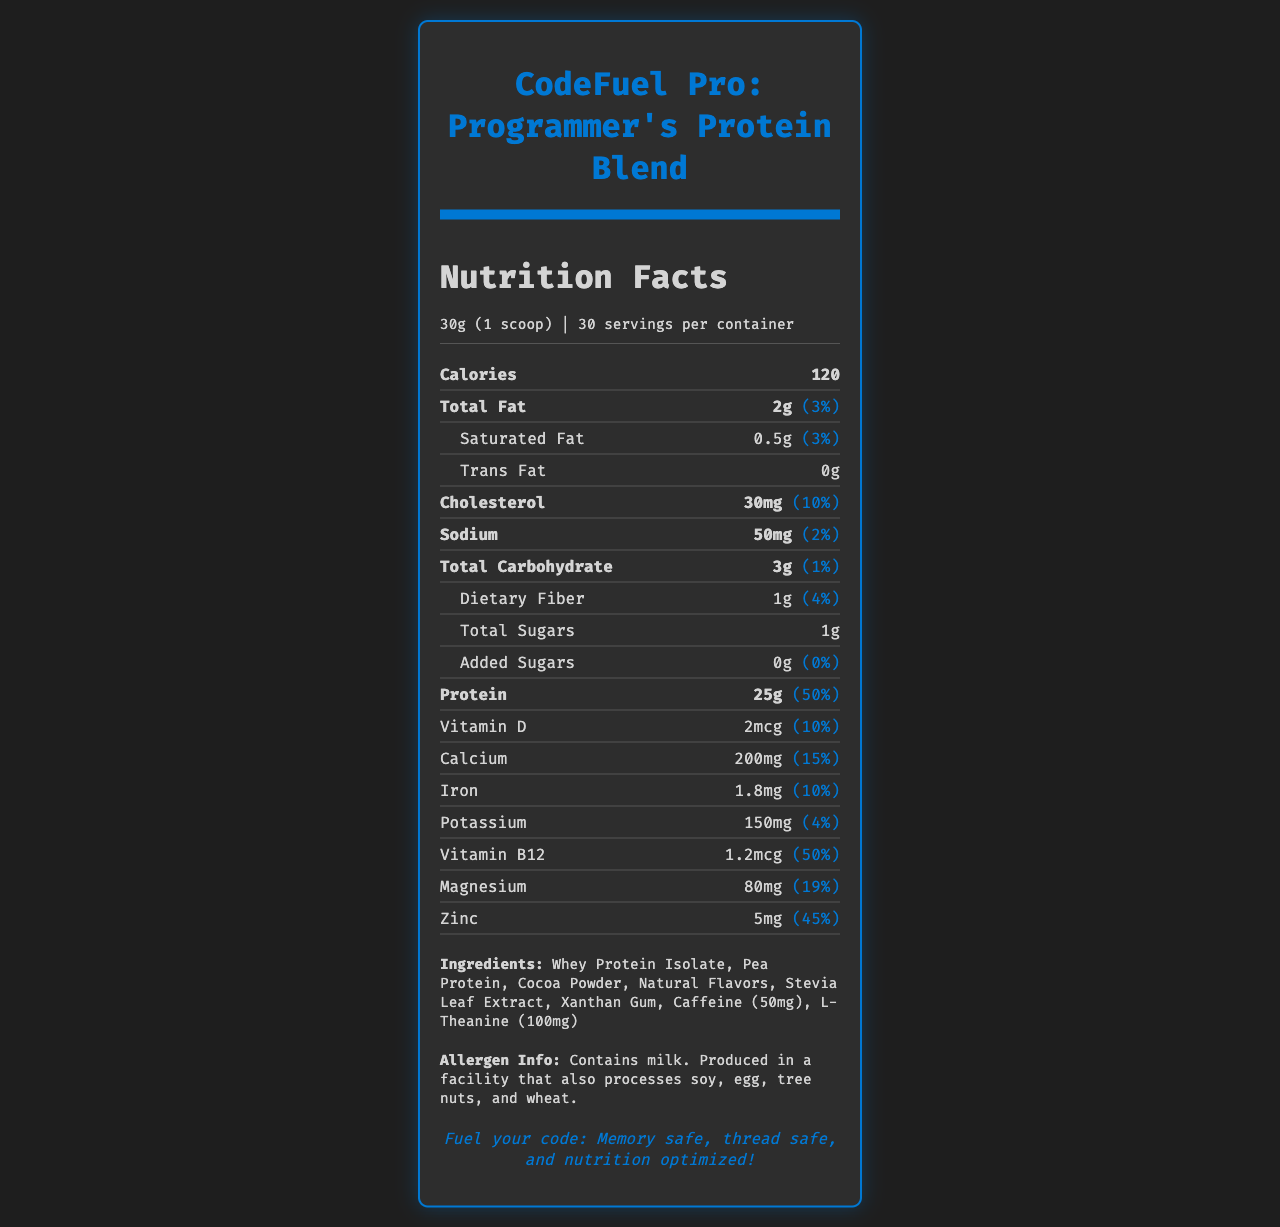What is the serving size of CodeFuel Pro? The serving size is clearly listed under the product name and nutrition facts.
Answer: 30g (1 scoop) How many calories are in one serving? The number of calories per serving is listed under the nutrition section.
Answer: 120 How much protein does one serving provide? The amount of protein per serving is listed in the nutrition facts.
Answer: 25g What is the daily value percentage for protein in one serving? The daily value percentage for protein is shown next to the protein amount in the nutrition facts.
Answer: 50% How much caffeine does one serving contain? Caffeine is listed as one of the ingredients with its specific amount.
Answer: 50mg How many servings are there in one container? The number of servings per container is stated in the serving information section.
Answer: 30 What is the amount of dietary fiber in one serving? The amount of dietary fiber is listed under the carbohydrates section of the nutrition facts.
Answer: 1g What is the storage recommendation for this product? The storage instructions are provided at the end of the document.
Answer: Store in a cool, dry place. Seal the container tightly after opening. Is this product ideal for muscle recovery after long hours of sitting? One of the marketing claims explicitly states that the product is rich in proteins to support muscle recovery.
Answer: Yes Which of the following nutrients is present in the highest amount in one serving? A. Sodium B. Calcium C. Protein D. Magnesium Protein is present in the highest amount (25g) compared to sodium (50mg), calcium (200mg), and magnesium (80mg).
Answer: C. Protein What is the daily value percentage for Vitamin B12 in one serving? A. 10% B. 15% C. 50% D. 19% The daily value percentage for Vitamin B12 is 50%, as stated next to its amount in the nutrition facts.
Answer: C. 50% Does this product contain added sugars? The document specifies that the amount of added sugars is 0g and the daily value is 0%.
Answer: No Summarize the main nutritional benefits of CodeFuel Pro: Programmer's Protein Blend. The summary encapsulates the main points from the nutrition facts and the marketing claims, highlighting the product's benefits and ingredients.
Answer: CodeFuel Pro provides a high amount of protein (25g per serving) with a low amount of total fat (2g) and carbohydrates (3g), designed to support cognitive function and muscle recovery. It also contains essential vitamins and minerals such as Vitamin D, Calcium, Iron, and Vitamin B12, and is enhanced with caffeine and L-Theanine to improve alertness and concentration. What is the exact amount of natural flavors used in the product? The document lists "Natural Flavors" as an ingredient but does not specify the exact amount.
Answer: Not enough information What are the main goals of CodeFuel Pro according to its marketing claims? This explanation is derived from the marketing claims section which lists the key benefits and goals of the product.
Answer: Supports cognitive function and focus, ideal macronutrient ratio for sustained energy during coding sessions, enhanced with caffeine and L-Theanine for improved alertness and concentration, low in carbs to prevent post-meal sluggishness, rich in proteins to support muscle recovery after long hours of sitting 